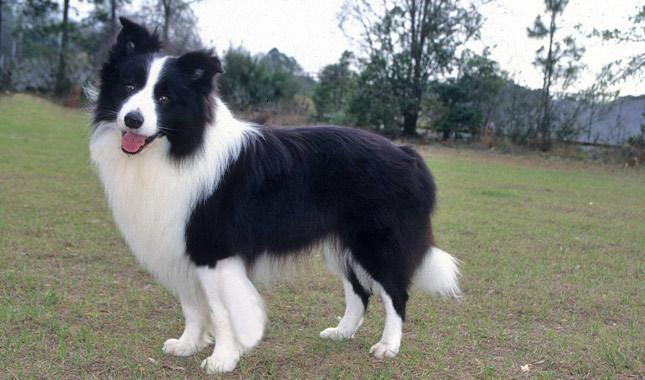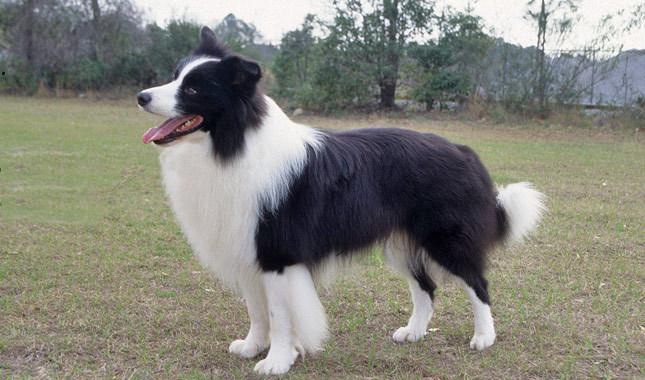The first image is the image on the left, the second image is the image on the right. Analyze the images presented: Is the assertion "There are two animals" valid? Answer yes or no. Yes. The first image is the image on the left, the second image is the image on the right. Given the left and right images, does the statement "One image shows two animals side-by-side with a plain backdrop." hold true? Answer yes or no. No. 